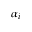<formula> <loc_0><loc_0><loc_500><loc_500>\alpha _ { i }</formula> 